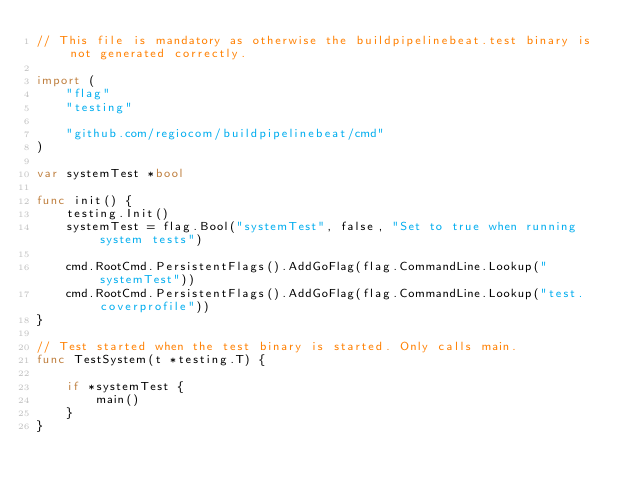Convert code to text. <code><loc_0><loc_0><loc_500><loc_500><_Go_>// This file is mandatory as otherwise the buildpipelinebeat.test binary is not generated correctly.

import (
	"flag"
	"testing"

	"github.com/regiocom/buildpipelinebeat/cmd"
)

var systemTest *bool

func init() {
	testing.Init()
	systemTest = flag.Bool("systemTest", false, "Set to true when running system tests")

	cmd.RootCmd.PersistentFlags().AddGoFlag(flag.CommandLine.Lookup("systemTest"))
	cmd.RootCmd.PersistentFlags().AddGoFlag(flag.CommandLine.Lookup("test.coverprofile"))
}

// Test started when the test binary is started. Only calls main.
func TestSystem(t *testing.T) {

	if *systemTest {
		main()
	}
}
</code> 